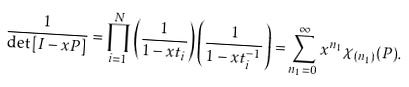Convert formula to latex. <formula><loc_0><loc_0><loc_500><loc_500>\frac { 1 } { \det \left [ I - x P \right ] } = \prod _ { i = 1 } ^ { N } \left ( \frac { 1 } { 1 - x t _ { i } } \right ) \left ( \frac { 1 } { 1 - x t _ { i } ^ { - 1 } } \right ) = \sum _ { n _ { 1 } = 0 } ^ { \infty } x ^ { n _ { 1 } } \chi _ { ( n _ { 1 } ) } ( P ) .</formula> 